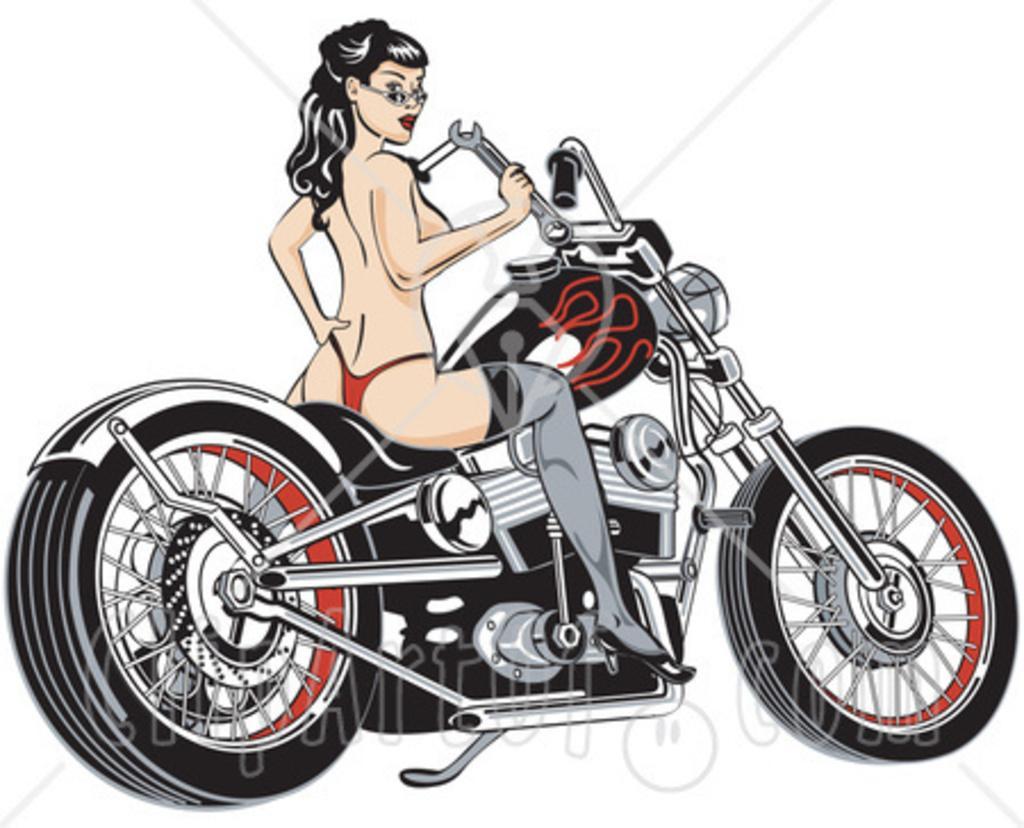How would you summarize this image in a sentence or two? This is an animated image. In this image I can see the person sitting on the motorbike. I can see there is a white background. 